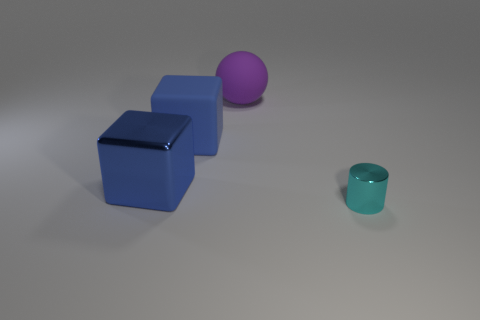Is the shape of the shiny thing left of the tiny cyan thing the same as  the cyan thing?
Give a very brief answer. No. Is the number of small objects that are left of the rubber block greater than the number of large green cubes?
Make the answer very short. No. The thing in front of the metal thing that is behind the tiny cylinder is what color?
Give a very brief answer. Cyan. How many yellow cylinders are there?
Offer a terse response. 0. How many shiny things are on the right side of the large purple rubber thing and behind the cyan metal object?
Offer a terse response. 0. Are there any other things that have the same shape as the tiny metallic object?
Your answer should be very brief. No. There is a metallic cube; does it have the same color as the big block behind the blue metallic cube?
Provide a succinct answer. Yes. There is a rubber object that is to the left of the large purple matte ball; what is its shape?
Make the answer very short. Cube. How many other objects are there of the same material as the cyan object?
Your answer should be compact. 1. What is the material of the cyan cylinder?
Provide a succinct answer. Metal. 